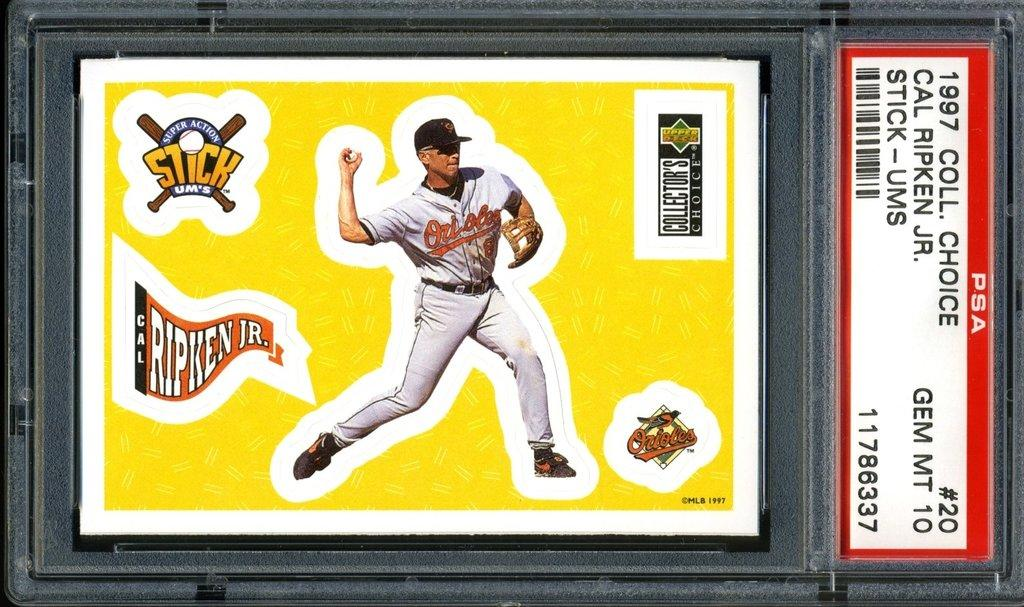<image>
Relay a brief, clear account of the picture shown. A baseball card with the flag for Ripken Jr. on the bottom left side of it. 